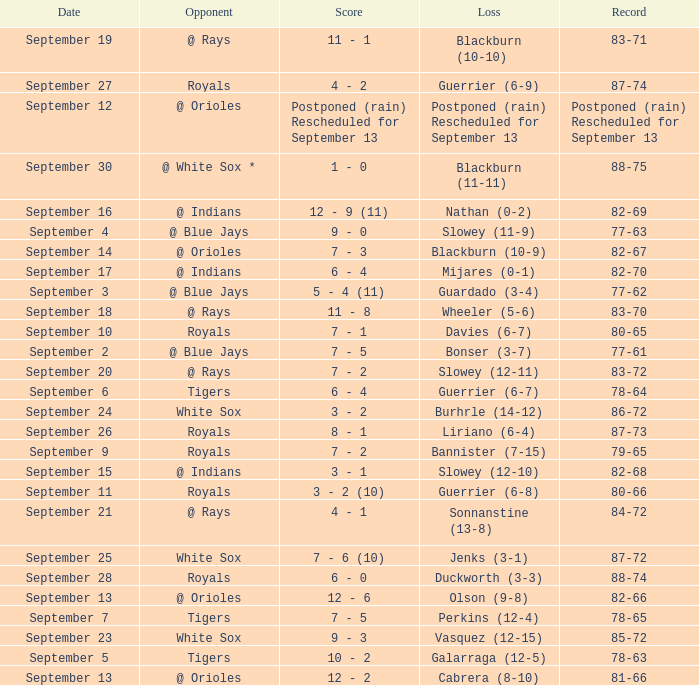What opponent has the record of 78-63? Tigers. 